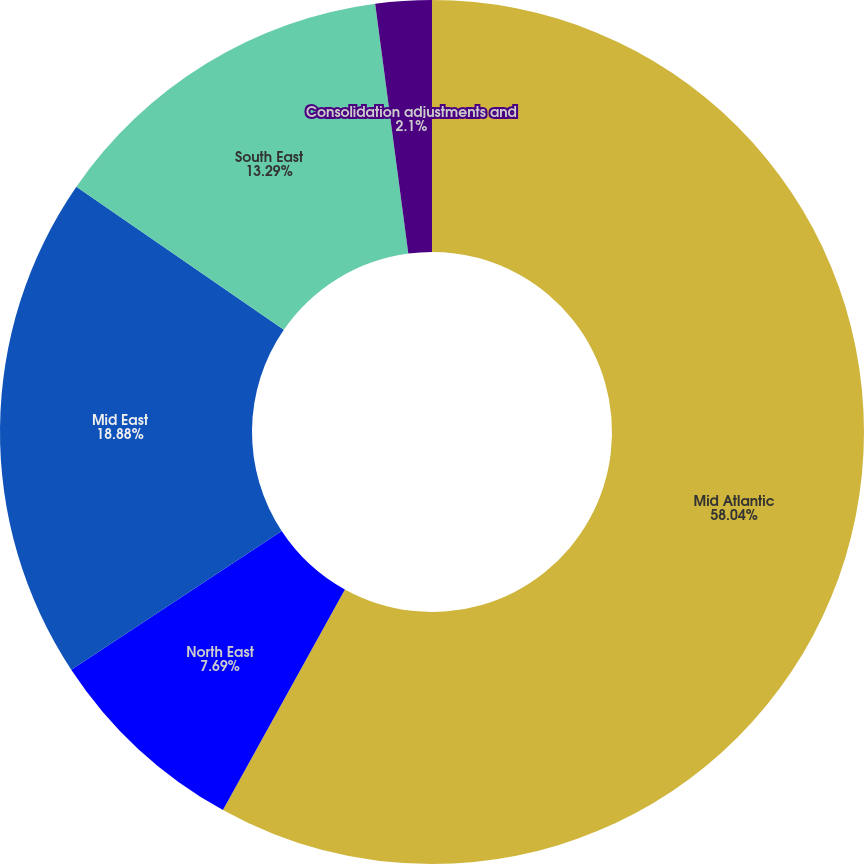<chart> <loc_0><loc_0><loc_500><loc_500><pie_chart><fcel>Mid Atlantic<fcel>North East<fcel>Mid East<fcel>South East<fcel>Consolidation adjustments and<nl><fcel>58.04%<fcel>7.69%<fcel>18.88%<fcel>13.29%<fcel>2.1%<nl></chart> 